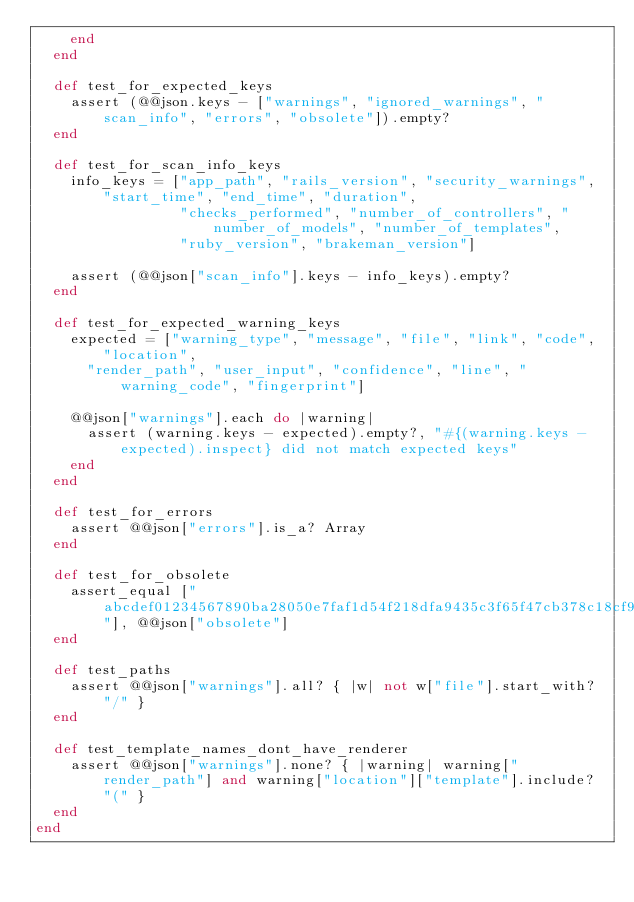<code> <loc_0><loc_0><loc_500><loc_500><_Ruby_>    end
  end

  def test_for_expected_keys
    assert (@@json.keys - ["warnings", "ignored_warnings", "scan_info", "errors", "obsolete"]).empty?
  end

  def test_for_scan_info_keys
    info_keys = ["app_path", "rails_version", "security_warnings", "start_time", "end_time", "duration",
                 "checks_performed", "number_of_controllers", "number_of_models", "number_of_templates",
                 "ruby_version", "brakeman_version"]

    assert (@@json["scan_info"].keys - info_keys).empty?
  end

  def test_for_expected_warning_keys
    expected = ["warning_type", "message", "file", "link", "code", "location",
      "render_path", "user_input", "confidence", "line", "warning_code", "fingerprint"]

    @@json["warnings"].each do |warning|
      assert (warning.keys - expected).empty?, "#{(warning.keys - expected).inspect} did not match expected keys"
    end
  end

  def test_for_errors
    assert @@json["errors"].is_a? Array
  end

  def test_for_obsolete
    assert_equal ["abcdef01234567890ba28050e7faf1d54f218dfa9435c3f65f47cb378c18cf98"], @@json["obsolete"]
  end

  def test_paths
    assert @@json["warnings"].all? { |w| not w["file"].start_with? "/" }
  end

  def test_template_names_dont_have_renderer
    assert @@json["warnings"].none? { |warning| warning["render_path"] and warning["location"]["template"].include? "(" }
  end
end
</code> 